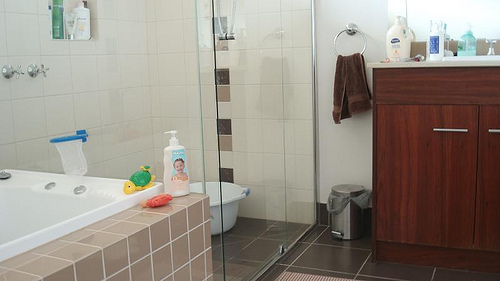Please provide the bounding box coordinate of the region this sentence describes: the pump on the bottle. The coordinates for the region showing the pump on the bottle are [0.33, 0.48, 0.36, 0.51]. 